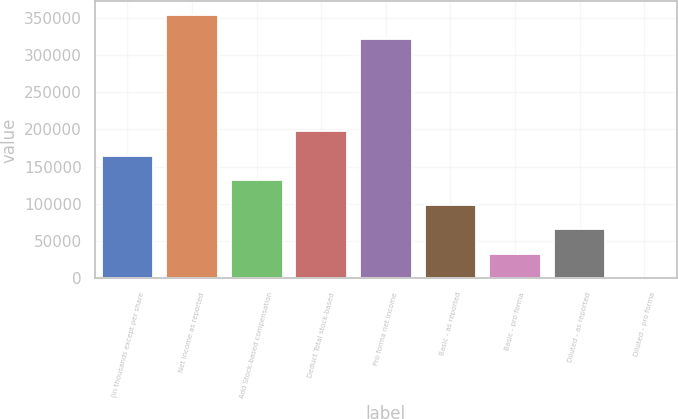Convert chart. <chart><loc_0><loc_0><loc_500><loc_500><bar_chart><fcel>(in thousands except per share<fcel>Net income as reported<fcel>Add Stock-based compensation<fcel>Deduct Total stock-based<fcel>Pro forma net income<fcel>Basic - as reported<fcel>Basic - pro forma<fcel>Diluted - as reported<fcel>Diluted - pro forma<nl><fcel>164358<fcel>354253<fcel>131487<fcel>197228<fcel>321383<fcel>98616.8<fcel>32875.9<fcel>65746.4<fcel>5.43<nl></chart> 